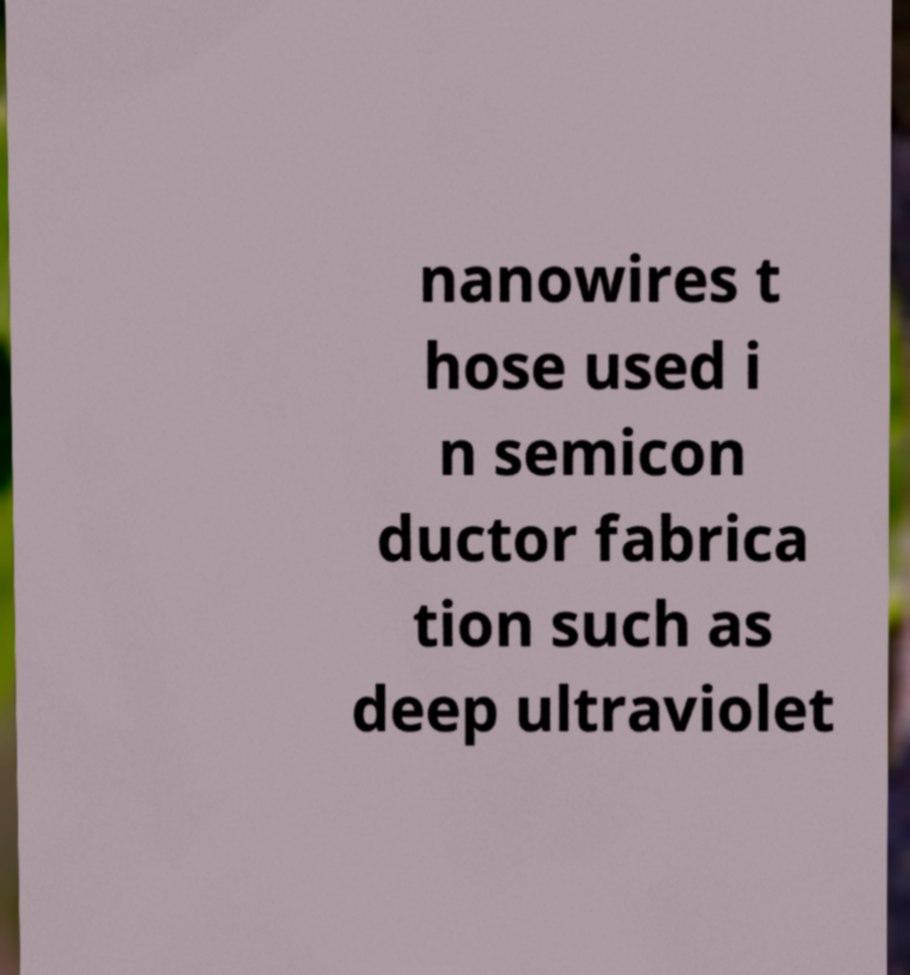For documentation purposes, I need the text within this image transcribed. Could you provide that? nanowires t hose used i n semicon ductor fabrica tion such as deep ultraviolet 